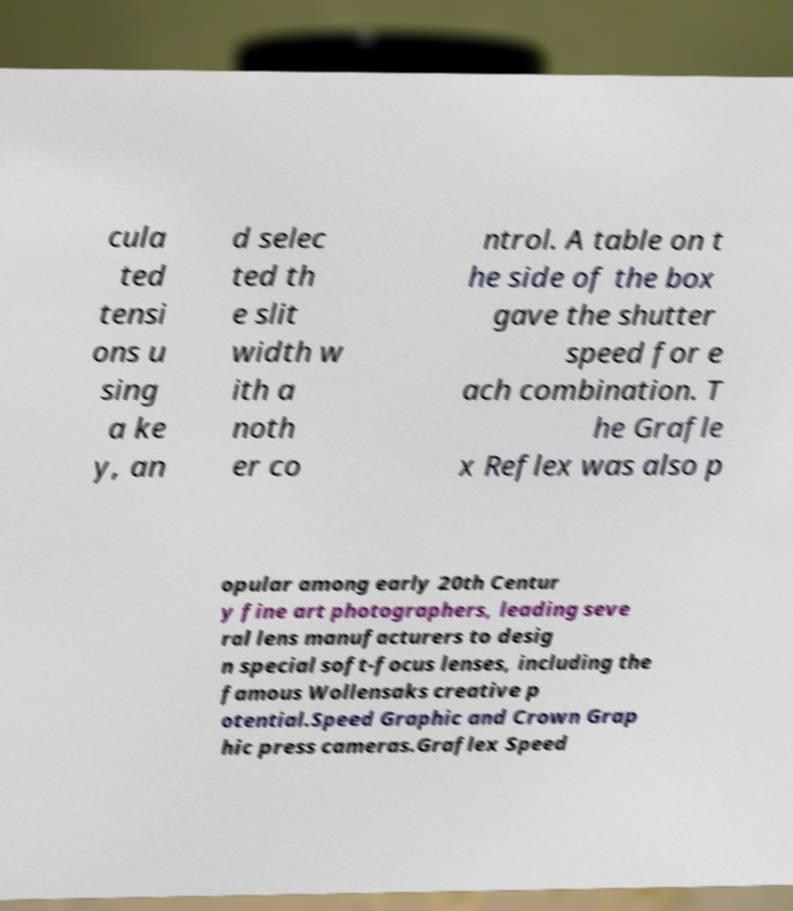I need the written content from this picture converted into text. Can you do that? cula ted tensi ons u sing a ke y, an d selec ted th e slit width w ith a noth er co ntrol. A table on t he side of the box gave the shutter speed for e ach combination. T he Grafle x Reflex was also p opular among early 20th Centur y fine art photographers, leading seve ral lens manufacturers to desig n special soft-focus lenses, including the famous Wollensaks creative p otential.Speed Graphic and Crown Grap hic press cameras.Graflex Speed 